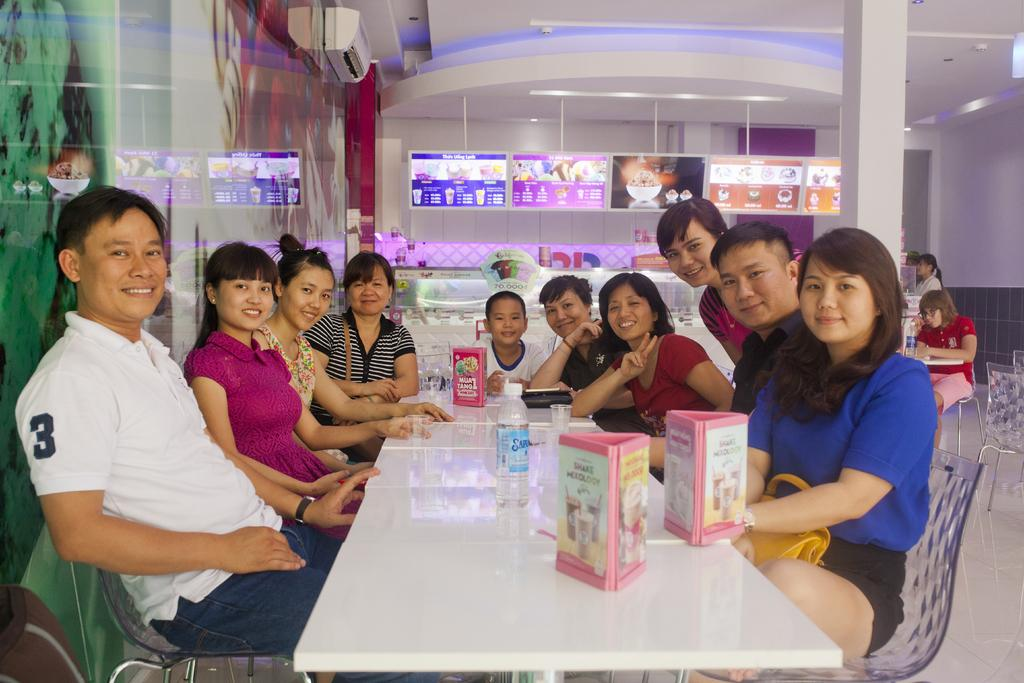What are the people in the image doing? The people in the image are sitting on chairs. What is in front of the chairs? There is a table in front of the chairs. What can be seen on the table? There are objects placed on the table. Can you describe the people visible behind the chairs? There are people visible behind the chairs. What type of tank can be seen in the image? There is no tank present in the image. How tall are the giants in the image? There are no giants present in the image. 